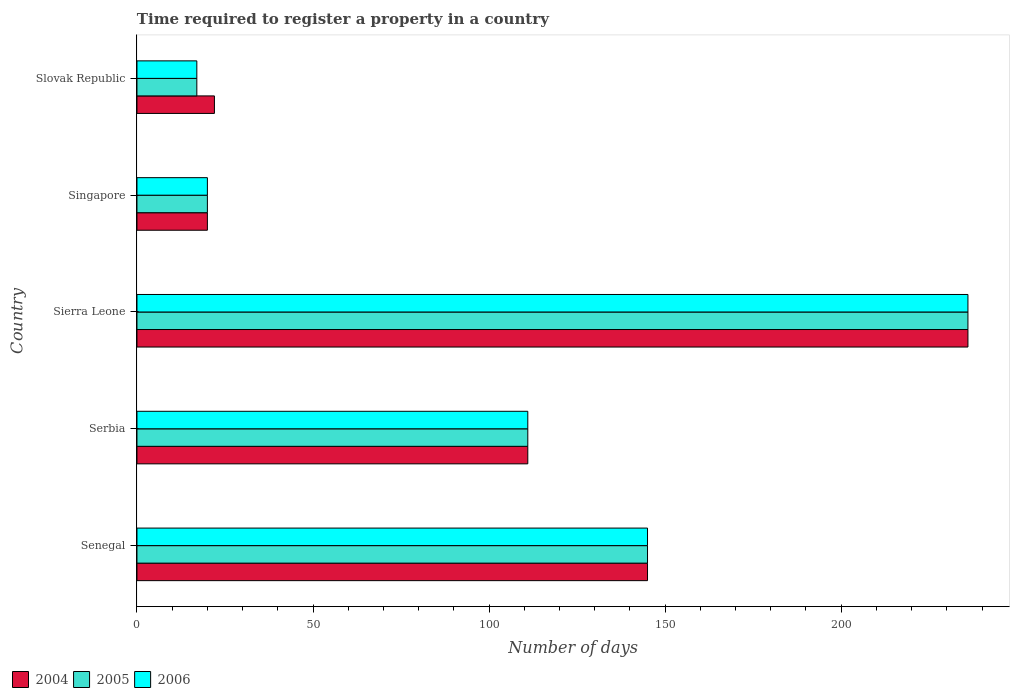How many groups of bars are there?
Offer a terse response. 5. What is the label of the 5th group of bars from the top?
Provide a succinct answer. Senegal. What is the number of days required to register a property in 2006 in Sierra Leone?
Ensure brevity in your answer.  236. Across all countries, what is the maximum number of days required to register a property in 2004?
Your answer should be compact. 236. In which country was the number of days required to register a property in 2004 maximum?
Provide a succinct answer. Sierra Leone. In which country was the number of days required to register a property in 2004 minimum?
Offer a very short reply. Singapore. What is the total number of days required to register a property in 2004 in the graph?
Keep it short and to the point. 534. What is the difference between the number of days required to register a property in 2005 in Senegal and that in Slovak Republic?
Offer a very short reply. 128. What is the difference between the number of days required to register a property in 2005 in Serbia and the number of days required to register a property in 2004 in Slovak Republic?
Your answer should be very brief. 89. What is the average number of days required to register a property in 2006 per country?
Your answer should be compact. 105.8. What is the difference between the number of days required to register a property in 2006 and number of days required to register a property in 2004 in Sierra Leone?
Ensure brevity in your answer.  0. What is the ratio of the number of days required to register a property in 2006 in Senegal to that in Singapore?
Your response must be concise. 7.25. Is the number of days required to register a property in 2006 in Serbia less than that in Sierra Leone?
Provide a short and direct response. Yes. Is the difference between the number of days required to register a property in 2006 in Senegal and Slovak Republic greater than the difference between the number of days required to register a property in 2004 in Senegal and Slovak Republic?
Offer a very short reply. Yes. What is the difference between the highest and the second highest number of days required to register a property in 2005?
Your response must be concise. 91. What is the difference between the highest and the lowest number of days required to register a property in 2006?
Your answer should be very brief. 219. In how many countries, is the number of days required to register a property in 2006 greater than the average number of days required to register a property in 2006 taken over all countries?
Your answer should be compact. 3. Is the sum of the number of days required to register a property in 2006 in Senegal and Sierra Leone greater than the maximum number of days required to register a property in 2005 across all countries?
Provide a succinct answer. Yes. What does the 3rd bar from the top in Singapore represents?
Offer a terse response. 2004. What does the 2nd bar from the bottom in Slovak Republic represents?
Your answer should be compact. 2005. Is it the case that in every country, the sum of the number of days required to register a property in 2004 and number of days required to register a property in 2005 is greater than the number of days required to register a property in 2006?
Your answer should be very brief. Yes. Are all the bars in the graph horizontal?
Your answer should be very brief. Yes. What is the difference between two consecutive major ticks on the X-axis?
Keep it short and to the point. 50. Does the graph contain any zero values?
Make the answer very short. No. Does the graph contain grids?
Your response must be concise. No. How are the legend labels stacked?
Ensure brevity in your answer.  Horizontal. What is the title of the graph?
Keep it short and to the point. Time required to register a property in a country. What is the label or title of the X-axis?
Provide a succinct answer. Number of days. What is the label or title of the Y-axis?
Offer a terse response. Country. What is the Number of days of 2004 in Senegal?
Ensure brevity in your answer.  145. What is the Number of days in 2005 in Senegal?
Make the answer very short. 145. What is the Number of days in 2006 in Senegal?
Provide a succinct answer. 145. What is the Number of days in 2004 in Serbia?
Keep it short and to the point. 111. What is the Number of days in 2005 in Serbia?
Give a very brief answer. 111. What is the Number of days of 2006 in Serbia?
Make the answer very short. 111. What is the Number of days in 2004 in Sierra Leone?
Provide a short and direct response. 236. What is the Number of days in 2005 in Sierra Leone?
Your answer should be very brief. 236. What is the Number of days of 2006 in Sierra Leone?
Keep it short and to the point. 236. What is the Number of days in 2005 in Singapore?
Ensure brevity in your answer.  20. What is the Number of days of 2006 in Singapore?
Ensure brevity in your answer.  20. What is the Number of days of 2004 in Slovak Republic?
Offer a terse response. 22. What is the Number of days of 2006 in Slovak Republic?
Make the answer very short. 17. Across all countries, what is the maximum Number of days in 2004?
Offer a very short reply. 236. Across all countries, what is the maximum Number of days of 2005?
Provide a succinct answer. 236. Across all countries, what is the maximum Number of days of 2006?
Provide a short and direct response. 236. Across all countries, what is the minimum Number of days in 2004?
Offer a terse response. 20. Across all countries, what is the minimum Number of days in 2005?
Give a very brief answer. 17. What is the total Number of days in 2004 in the graph?
Provide a short and direct response. 534. What is the total Number of days of 2005 in the graph?
Your answer should be compact. 529. What is the total Number of days in 2006 in the graph?
Your answer should be compact. 529. What is the difference between the Number of days of 2004 in Senegal and that in Serbia?
Keep it short and to the point. 34. What is the difference between the Number of days in 2004 in Senegal and that in Sierra Leone?
Give a very brief answer. -91. What is the difference between the Number of days of 2005 in Senegal and that in Sierra Leone?
Offer a very short reply. -91. What is the difference between the Number of days of 2006 in Senegal and that in Sierra Leone?
Make the answer very short. -91. What is the difference between the Number of days in 2004 in Senegal and that in Singapore?
Provide a succinct answer. 125. What is the difference between the Number of days of 2005 in Senegal and that in Singapore?
Provide a short and direct response. 125. What is the difference between the Number of days in 2006 in Senegal and that in Singapore?
Offer a very short reply. 125. What is the difference between the Number of days in 2004 in Senegal and that in Slovak Republic?
Your response must be concise. 123. What is the difference between the Number of days in 2005 in Senegal and that in Slovak Republic?
Your answer should be compact. 128. What is the difference between the Number of days in 2006 in Senegal and that in Slovak Republic?
Your response must be concise. 128. What is the difference between the Number of days in 2004 in Serbia and that in Sierra Leone?
Give a very brief answer. -125. What is the difference between the Number of days in 2005 in Serbia and that in Sierra Leone?
Your answer should be very brief. -125. What is the difference between the Number of days in 2006 in Serbia and that in Sierra Leone?
Provide a succinct answer. -125. What is the difference between the Number of days in 2004 in Serbia and that in Singapore?
Make the answer very short. 91. What is the difference between the Number of days of 2005 in Serbia and that in Singapore?
Your answer should be compact. 91. What is the difference between the Number of days of 2006 in Serbia and that in Singapore?
Offer a terse response. 91. What is the difference between the Number of days of 2004 in Serbia and that in Slovak Republic?
Offer a terse response. 89. What is the difference between the Number of days in 2005 in Serbia and that in Slovak Republic?
Offer a very short reply. 94. What is the difference between the Number of days of 2006 in Serbia and that in Slovak Republic?
Provide a succinct answer. 94. What is the difference between the Number of days in 2004 in Sierra Leone and that in Singapore?
Provide a short and direct response. 216. What is the difference between the Number of days of 2005 in Sierra Leone and that in Singapore?
Give a very brief answer. 216. What is the difference between the Number of days in 2006 in Sierra Leone and that in Singapore?
Offer a terse response. 216. What is the difference between the Number of days in 2004 in Sierra Leone and that in Slovak Republic?
Your answer should be compact. 214. What is the difference between the Number of days of 2005 in Sierra Leone and that in Slovak Republic?
Provide a succinct answer. 219. What is the difference between the Number of days of 2006 in Sierra Leone and that in Slovak Republic?
Ensure brevity in your answer.  219. What is the difference between the Number of days in 2005 in Singapore and that in Slovak Republic?
Your answer should be very brief. 3. What is the difference between the Number of days in 2004 in Senegal and the Number of days in 2005 in Serbia?
Your answer should be compact. 34. What is the difference between the Number of days in 2005 in Senegal and the Number of days in 2006 in Serbia?
Make the answer very short. 34. What is the difference between the Number of days of 2004 in Senegal and the Number of days of 2005 in Sierra Leone?
Ensure brevity in your answer.  -91. What is the difference between the Number of days of 2004 in Senegal and the Number of days of 2006 in Sierra Leone?
Your answer should be compact. -91. What is the difference between the Number of days in 2005 in Senegal and the Number of days in 2006 in Sierra Leone?
Ensure brevity in your answer.  -91. What is the difference between the Number of days in 2004 in Senegal and the Number of days in 2005 in Singapore?
Your answer should be compact. 125. What is the difference between the Number of days of 2004 in Senegal and the Number of days of 2006 in Singapore?
Ensure brevity in your answer.  125. What is the difference between the Number of days in 2005 in Senegal and the Number of days in 2006 in Singapore?
Keep it short and to the point. 125. What is the difference between the Number of days of 2004 in Senegal and the Number of days of 2005 in Slovak Republic?
Make the answer very short. 128. What is the difference between the Number of days in 2004 in Senegal and the Number of days in 2006 in Slovak Republic?
Give a very brief answer. 128. What is the difference between the Number of days of 2005 in Senegal and the Number of days of 2006 in Slovak Republic?
Your response must be concise. 128. What is the difference between the Number of days of 2004 in Serbia and the Number of days of 2005 in Sierra Leone?
Make the answer very short. -125. What is the difference between the Number of days of 2004 in Serbia and the Number of days of 2006 in Sierra Leone?
Your answer should be very brief. -125. What is the difference between the Number of days of 2005 in Serbia and the Number of days of 2006 in Sierra Leone?
Provide a short and direct response. -125. What is the difference between the Number of days in 2004 in Serbia and the Number of days in 2005 in Singapore?
Your answer should be very brief. 91. What is the difference between the Number of days of 2004 in Serbia and the Number of days of 2006 in Singapore?
Offer a very short reply. 91. What is the difference between the Number of days in 2005 in Serbia and the Number of days in 2006 in Singapore?
Keep it short and to the point. 91. What is the difference between the Number of days of 2004 in Serbia and the Number of days of 2005 in Slovak Republic?
Give a very brief answer. 94. What is the difference between the Number of days of 2004 in Serbia and the Number of days of 2006 in Slovak Republic?
Your answer should be very brief. 94. What is the difference between the Number of days in 2005 in Serbia and the Number of days in 2006 in Slovak Republic?
Your response must be concise. 94. What is the difference between the Number of days in 2004 in Sierra Leone and the Number of days in 2005 in Singapore?
Your response must be concise. 216. What is the difference between the Number of days in 2004 in Sierra Leone and the Number of days in 2006 in Singapore?
Provide a succinct answer. 216. What is the difference between the Number of days of 2005 in Sierra Leone and the Number of days of 2006 in Singapore?
Your answer should be very brief. 216. What is the difference between the Number of days of 2004 in Sierra Leone and the Number of days of 2005 in Slovak Republic?
Offer a very short reply. 219. What is the difference between the Number of days in 2004 in Sierra Leone and the Number of days in 2006 in Slovak Republic?
Offer a terse response. 219. What is the difference between the Number of days of 2005 in Sierra Leone and the Number of days of 2006 in Slovak Republic?
Offer a very short reply. 219. What is the difference between the Number of days in 2005 in Singapore and the Number of days in 2006 in Slovak Republic?
Offer a very short reply. 3. What is the average Number of days of 2004 per country?
Your answer should be very brief. 106.8. What is the average Number of days in 2005 per country?
Provide a succinct answer. 105.8. What is the average Number of days of 2006 per country?
Offer a terse response. 105.8. What is the difference between the Number of days in 2004 and Number of days in 2005 in Senegal?
Make the answer very short. 0. What is the difference between the Number of days in 2004 and Number of days in 2006 in Senegal?
Make the answer very short. 0. What is the difference between the Number of days of 2004 and Number of days of 2006 in Serbia?
Make the answer very short. 0. What is the difference between the Number of days in 2005 and Number of days in 2006 in Serbia?
Keep it short and to the point. 0. What is the difference between the Number of days of 2005 and Number of days of 2006 in Sierra Leone?
Provide a short and direct response. 0. What is the difference between the Number of days of 2004 and Number of days of 2005 in Singapore?
Give a very brief answer. 0. What is the difference between the Number of days of 2004 and Number of days of 2006 in Singapore?
Offer a terse response. 0. What is the difference between the Number of days in 2005 and Number of days in 2006 in Singapore?
Offer a very short reply. 0. What is the difference between the Number of days in 2004 and Number of days in 2006 in Slovak Republic?
Offer a terse response. 5. What is the difference between the Number of days of 2005 and Number of days of 2006 in Slovak Republic?
Provide a short and direct response. 0. What is the ratio of the Number of days in 2004 in Senegal to that in Serbia?
Make the answer very short. 1.31. What is the ratio of the Number of days in 2005 in Senegal to that in Serbia?
Your response must be concise. 1.31. What is the ratio of the Number of days of 2006 in Senegal to that in Serbia?
Keep it short and to the point. 1.31. What is the ratio of the Number of days of 2004 in Senegal to that in Sierra Leone?
Give a very brief answer. 0.61. What is the ratio of the Number of days in 2005 in Senegal to that in Sierra Leone?
Keep it short and to the point. 0.61. What is the ratio of the Number of days of 2006 in Senegal to that in Sierra Leone?
Make the answer very short. 0.61. What is the ratio of the Number of days of 2004 in Senegal to that in Singapore?
Provide a short and direct response. 7.25. What is the ratio of the Number of days of 2005 in Senegal to that in Singapore?
Provide a short and direct response. 7.25. What is the ratio of the Number of days of 2006 in Senegal to that in Singapore?
Ensure brevity in your answer.  7.25. What is the ratio of the Number of days of 2004 in Senegal to that in Slovak Republic?
Make the answer very short. 6.59. What is the ratio of the Number of days in 2005 in Senegal to that in Slovak Republic?
Offer a terse response. 8.53. What is the ratio of the Number of days of 2006 in Senegal to that in Slovak Republic?
Your response must be concise. 8.53. What is the ratio of the Number of days of 2004 in Serbia to that in Sierra Leone?
Make the answer very short. 0.47. What is the ratio of the Number of days in 2005 in Serbia to that in Sierra Leone?
Keep it short and to the point. 0.47. What is the ratio of the Number of days in 2006 in Serbia to that in Sierra Leone?
Keep it short and to the point. 0.47. What is the ratio of the Number of days in 2004 in Serbia to that in Singapore?
Keep it short and to the point. 5.55. What is the ratio of the Number of days of 2005 in Serbia to that in Singapore?
Your answer should be compact. 5.55. What is the ratio of the Number of days in 2006 in Serbia to that in Singapore?
Keep it short and to the point. 5.55. What is the ratio of the Number of days in 2004 in Serbia to that in Slovak Republic?
Give a very brief answer. 5.05. What is the ratio of the Number of days in 2005 in Serbia to that in Slovak Republic?
Offer a very short reply. 6.53. What is the ratio of the Number of days in 2006 in Serbia to that in Slovak Republic?
Provide a succinct answer. 6.53. What is the ratio of the Number of days in 2005 in Sierra Leone to that in Singapore?
Provide a succinct answer. 11.8. What is the ratio of the Number of days in 2006 in Sierra Leone to that in Singapore?
Your answer should be compact. 11.8. What is the ratio of the Number of days in 2004 in Sierra Leone to that in Slovak Republic?
Ensure brevity in your answer.  10.73. What is the ratio of the Number of days of 2005 in Sierra Leone to that in Slovak Republic?
Your answer should be compact. 13.88. What is the ratio of the Number of days of 2006 in Sierra Leone to that in Slovak Republic?
Offer a very short reply. 13.88. What is the ratio of the Number of days of 2005 in Singapore to that in Slovak Republic?
Provide a succinct answer. 1.18. What is the ratio of the Number of days of 2006 in Singapore to that in Slovak Republic?
Offer a terse response. 1.18. What is the difference between the highest and the second highest Number of days of 2004?
Provide a short and direct response. 91. What is the difference between the highest and the second highest Number of days in 2005?
Your response must be concise. 91. What is the difference between the highest and the second highest Number of days of 2006?
Your answer should be very brief. 91. What is the difference between the highest and the lowest Number of days in 2004?
Make the answer very short. 216. What is the difference between the highest and the lowest Number of days of 2005?
Give a very brief answer. 219. What is the difference between the highest and the lowest Number of days in 2006?
Provide a short and direct response. 219. 